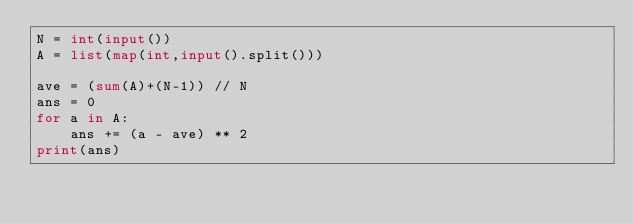<code> <loc_0><loc_0><loc_500><loc_500><_Python_>N = int(input())
A = list(map(int,input().split()))

ave = (sum(A)+(N-1)) // N
ans = 0
for a in A:
    ans += (a - ave) ** 2
print(ans)</code> 